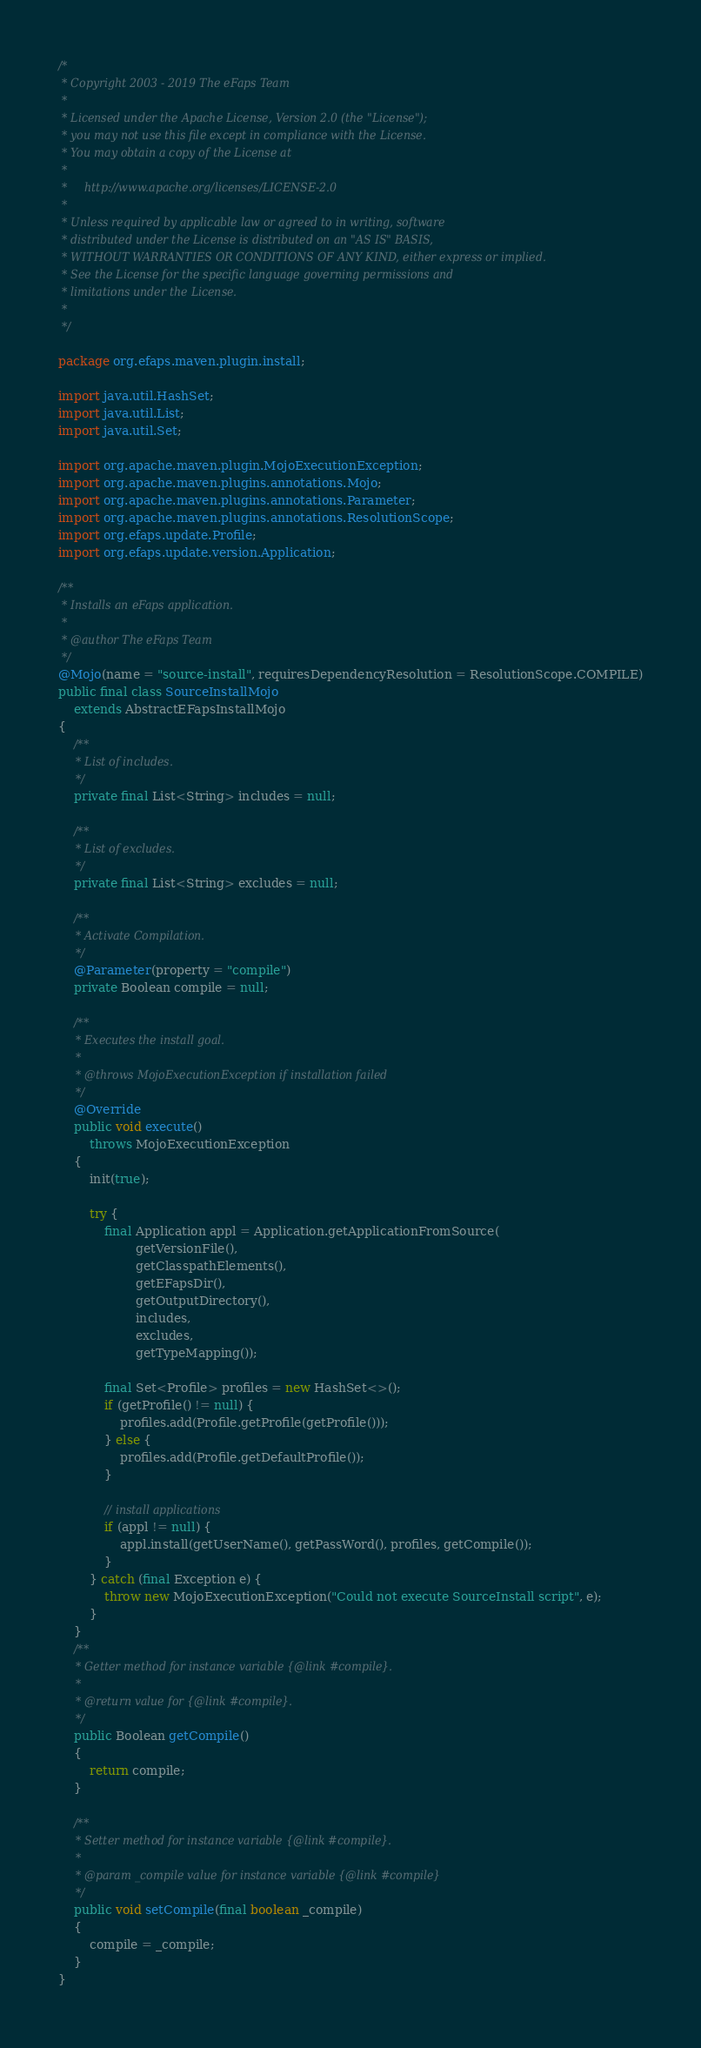<code> <loc_0><loc_0><loc_500><loc_500><_Java_>/*
 * Copyright 2003 - 2019 The eFaps Team
 *
 * Licensed under the Apache License, Version 2.0 (the "License");
 * you may not use this file except in compliance with the License.
 * You may obtain a copy of the License at
 *
 *     http://www.apache.org/licenses/LICENSE-2.0
 *
 * Unless required by applicable law or agreed to in writing, software
 * distributed under the License is distributed on an "AS IS" BASIS,
 * WITHOUT WARRANTIES OR CONDITIONS OF ANY KIND, either express or implied.
 * See the License for the specific language governing permissions and
 * limitations under the License.
 *
 */

package org.efaps.maven.plugin.install;

import java.util.HashSet;
import java.util.List;
import java.util.Set;

import org.apache.maven.plugin.MojoExecutionException;
import org.apache.maven.plugins.annotations.Mojo;
import org.apache.maven.plugins.annotations.Parameter;
import org.apache.maven.plugins.annotations.ResolutionScope;
import org.efaps.update.Profile;
import org.efaps.update.version.Application;

/**
 * Installs an eFaps application.
 *
 * @author The eFaps Team
 */
@Mojo(name = "source-install", requiresDependencyResolution = ResolutionScope.COMPILE)
public final class SourceInstallMojo
    extends AbstractEFapsInstallMojo
{
    /**
     * List of includes.
     */
    private final List<String> includes = null;

    /**
     * List of excludes.
     */
    private final List<String> excludes = null;

    /**
     * Activate Compilation.
     */
    @Parameter(property = "compile")
    private Boolean compile = null;

    /**
     * Executes the install goal.
     *
     * @throws MojoExecutionException if installation failed
     */
    @Override
    public void execute()
        throws MojoExecutionException
    {
        init(true);

        try {
            final Application appl = Application.getApplicationFromSource(
                    getVersionFile(),
                    getClasspathElements(),
                    getEFapsDir(),
                    getOutputDirectory(),
                    includes,
                    excludes,
                    getTypeMapping());

            final Set<Profile> profiles = new HashSet<>();
            if (getProfile() != null) {
                profiles.add(Profile.getProfile(getProfile()));
            } else {
                profiles.add(Profile.getDefaultProfile());
            }

            // install applications
            if (appl != null) {
                appl.install(getUserName(), getPassWord(), profiles, getCompile());
            }
        } catch (final Exception e) {
            throw new MojoExecutionException("Could not execute SourceInstall script", e);
        }
    }
    /**
     * Getter method for instance variable {@link #compile}.
     *
     * @return value for {@link #compile}.
     */
    public Boolean getCompile()
    {
        return compile;
    }

    /**
     * Setter method for instance variable {@link #compile}.
     *
     * @param _compile value for instance variable {@link #compile}
     */
    public void setCompile(final boolean _compile)
    {
        compile = _compile;
    }
}
</code> 